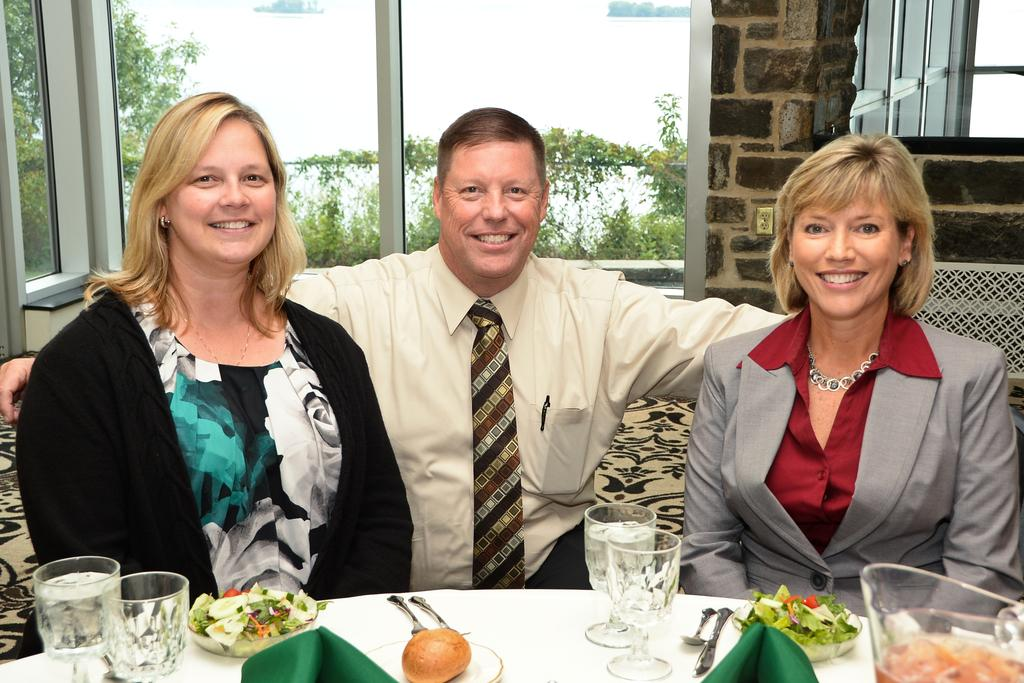What are the people doing in the image? The people are standing on a chair. What is present in the image besides the people on the chair? There is a table in the image. What can be seen on the table? There are wine glasses, spoons, forks, and a bowl with food items on the table. What type of gate can be seen in the image? There is no gate present in the image. Is there a tiger sitting on the table in the image? No, there is no tiger present in the image. 